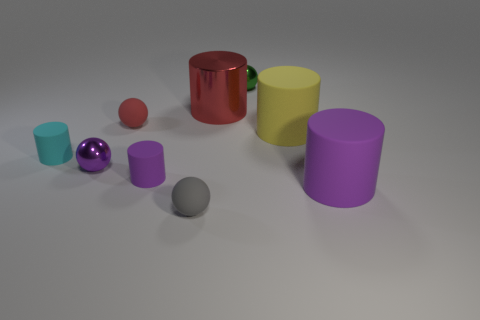Subtract all small gray matte spheres. How many spheres are left? 3 Subtract all red spheres. How many spheres are left? 3 Add 1 tiny gray things. How many objects exist? 10 Subtract 3 balls. How many balls are left? 1 Subtract all red cylinders. Subtract all red blocks. How many cylinders are left? 4 Subtract all red cubes. How many gray balls are left? 1 Subtract all tiny gray matte balls. Subtract all tiny gray matte objects. How many objects are left? 7 Add 7 yellow objects. How many yellow objects are left? 8 Add 2 green balls. How many green balls exist? 3 Subtract 0 blue cylinders. How many objects are left? 9 